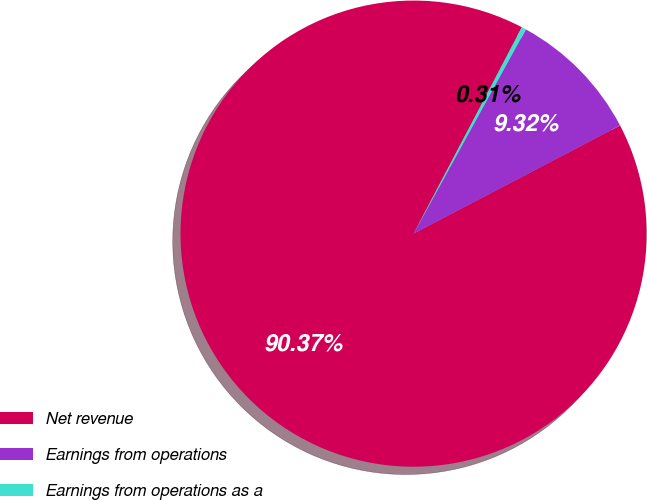Convert chart to OTSL. <chart><loc_0><loc_0><loc_500><loc_500><pie_chart><fcel>Net revenue<fcel>Earnings from operations<fcel>Earnings from operations as a<nl><fcel>90.37%<fcel>9.32%<fcel>0.31%<nl></chart> 